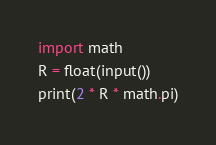<code> <loc_0><loc_0><loc_500><loc_500><_Python_>import math
R = float(input())
print(2 * R * math.pi)</code> 